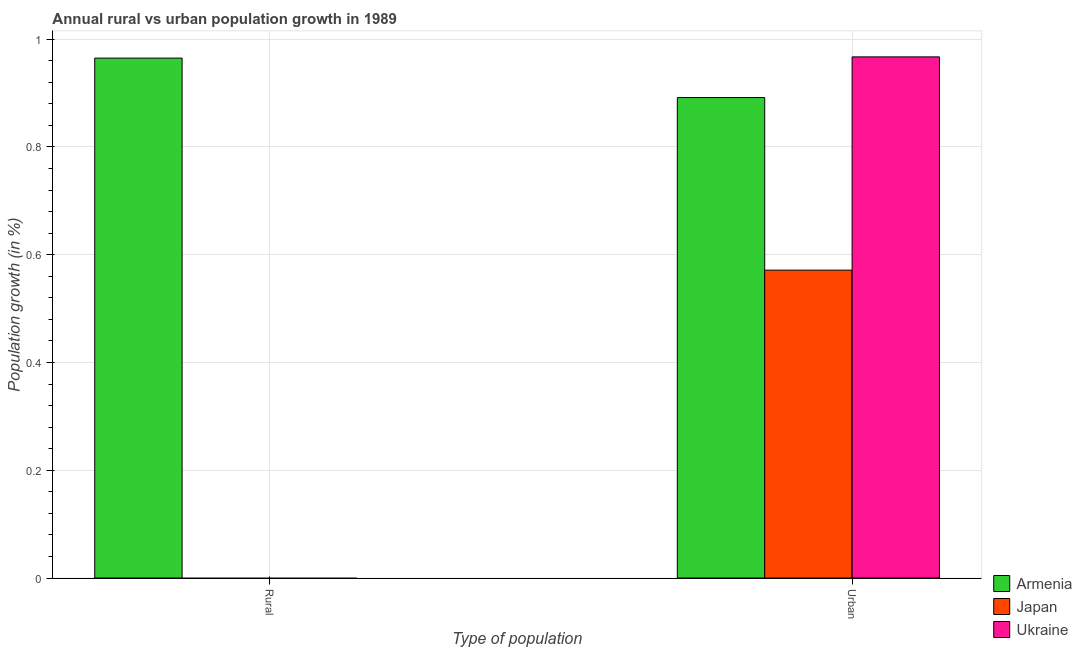How many bars are there on the 2nd tick from the right?
Provide a short and direct response. 1. What is the label of the 1st group of bars from the left?
Offer a terse response. Rural. What is the urban population growth in Armenia?
Keep it short and to the point. 0.89. Across all countries, what is the maximum rural population growth?
Provide a succinct answer. 0.96. In which country was the urban population growth maximum?
Your answer should be compact. Ukraine. What is the total urban population growth in the graph?
Keep it short and to the point. 2.43. What is the difference between the urban population growth in Ukraine and that in Japan?
Your answer should be very brief. 0.4. What is the difference between the rural population growth in Japan and the urban population growth in Armenia?
Your response must be concise. -0.89. What is the average rural population growth per country?
Provide a short and direct response. 0.32. What is the difference between the urban population growth and rural population growth in Armenia?
Your response must be concise. -0.07. In how many countries, is the urban population growth greater than 0.16 %?
Offer a very short reply. 3. What is the ratio of the urban population growth in Japan to that in Armenia?
Your response must be concise. 0.64. Is the urban population growth in Armenia less than that in Ukraine?
Your response must be concise. Yes. How many bars are there?
Provide a succinct answer. 4. How many countries are there in the graph?
Give a very brief answer. 3. What is the difference between two consecutive major ticks on the Y-axis?
Make the answer very short. 0.2. How many legend labels are there?
Make the answer very short. 3. What is the title of the graph?
Make the answer very short. Annual rural vs urban population growth in 1989. What is the label or title of the X-axis?
Your answer should be very brief. Type of population. What is the label or title of the Y-axis?
Give a very brief answer. Population growth (in %). What is the Population growth (in %) in Armenia in Rural?
Give a very brief answer. 0.96. What is the Population growth (in %) in Ukraine in Rural?
Ensure brevity in your answer.  0. What is the Population growth (in %) of Armenia in Urban ?
Your answer should be compact. 0.89. What is the Population growth (in %) in Japan in Urban ?
Offer a terse response. 0.57. What is the Population growth (in %) of Ukraine in Urban ?
Offer a terse response. 0.97. Across all Type of population, what is the maximum Population growth (in %) in Armenia?
Your answer should be compact. 0.96. Across all Type of population, what is the maximum Population growth (in %) in Japan?
Provide a succinct answer. 0.57. Across all Type of population, what is the maximum Population growth (in %) of Ukraine?
Your answer should be very brief. 0.97. Across all Type of population, what is the minimum Population growth (in %) in Armenia?
Your answer should be very brief. 0.89. Across all Type of population, what is the minimum Population growth (in %) in Japan?
Ensure brevity in your answer.  0. Across all Type of population, what is the minimum Population growth (in %) in Ukraine?
Provide a succinct answer. 0. What is the total Population growth (in %) in Armenia in the graph?
Your answer should be very brief. 1.86. What is the total Population growth (in %) of Japan in the graph?
Keep it short and to the point. 0.57. What is the total Population growth (in %) in Ukraine in the graph?
Offer a terse response. 0.97. What is the difference between the Population growth (in %) in Armenia in Rural and that in Urban ?
Offer a very short reply. 0.07. What is the difference between the Population growth (in %) of Armenia in Rural and the Population growth (in %) of Japan in Urban?
Your response must be concise. 0.39. What is the difference between the Population growth (in %) in Armenia in Rural and the Population growth (in %) in Ukraine in Urban?
Your answer should be very brief. -0. What is the average Population growth (in %) of Armenia per Type of population?
Your answer should be compact. 0.93. What is the average Population growth (in %) in Japan per Type of population?
Your response must be concise. 0.29. What is the average Population growth (in %) of Ukraine per Type of population?
Make the answer very short. 0.48. What is the difference between the Population growth (in %) of Armenia and Population growth (in %) of Japan in Urban ?
Give a very brief answer. 0.32. What is the difference between the Population growth (in %) in Armenia and Population growth (in %) in Ukraine in Urban ?
Ensure brevity in your answer.  -0.08. What is the difference between the Population growth (in %) in Japan and Population growth (in %) in Ukraine in Urban ?
Offer a very short reply. -0.4. What is the ratio of the Population growth (in %) in Armenia in Rural to that in Urban ?
Offer a terse response. 1.08. What is the difference between the highest and the second highest Population growth (in %) of Armenia?
Provide a short and direct response. 0.07. What is the difference between the highest and the lowest Population growth (in %) in Armenia?
Provide a succinct answer. 0.07. What is the difference between the highest and the lowest Population growth (in %) in Japan?
Your answer should be very brief. 0.57. What is the difference between the highest and the lowest Population growth (in %) of Ukraine?
Provide a succinct answer. 0.97. 